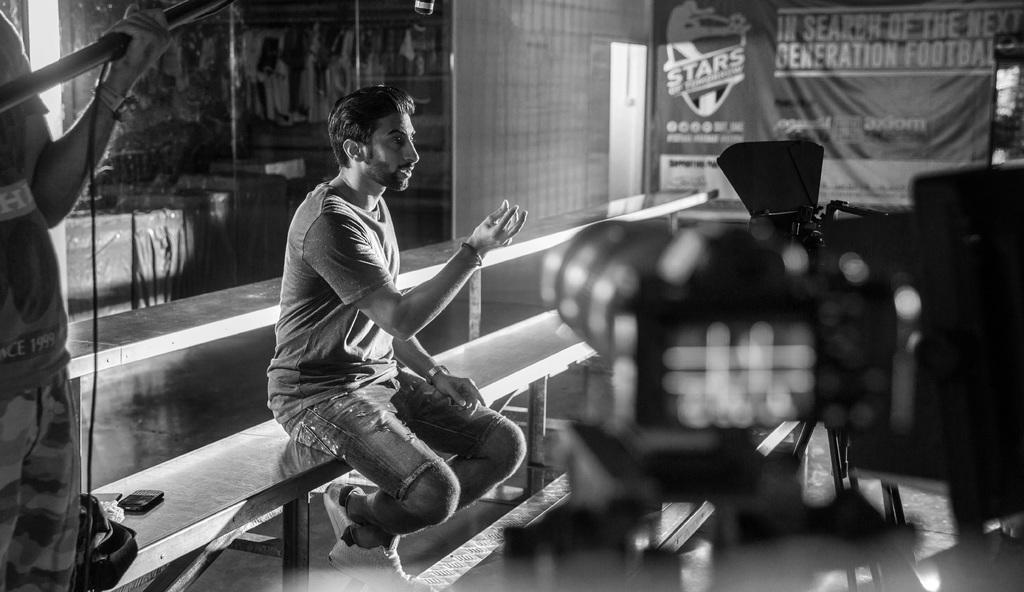What is the color scheme of the image? The image is black and white. What piece of furniture is present in the image? There is a bench in the image. Who is sitting on the bench? A person is sitting on the bench. What is located at the top of the image? There is a banner at the top of the image. Can you describe the person on the left side of the image? There is a person on the left side of the image. How many ears of corn are visible in the image? There are no ears of corn present in the image. What type of visitor can be seen in the image? There is no visitor present in the image; only a person sitting on a bench and another person on the left side are visible. 